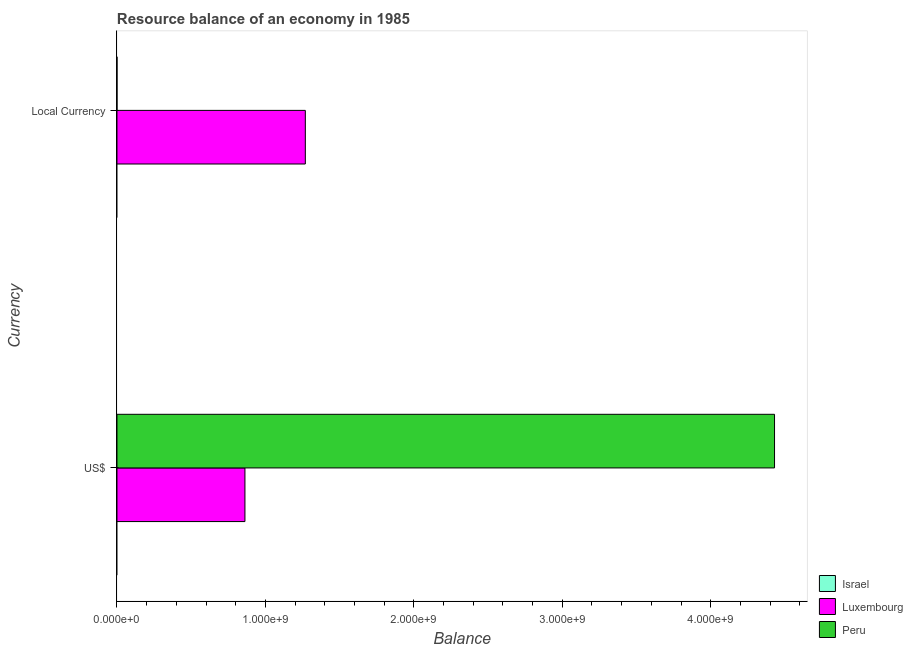How many groups of bars are there?
Give a very brief answer. 2. How many bars are there on the 1st tick from the top?
Ensure brevity in your answer.  2. What is the label of the 2nd group of bars from the top?
Your response must be concise. US$. What is the resource balance in constant us$ in Luxembourg?
Your response must be concise. 1.27e+09. Across all countries, what is the maximum resource balance in us$?
Provide a short and direct response. 4.43e+09. Across all countries, what is the minimum resource balance in constant us$?
Give a very brief answer. 0. In which country was the resource balance in constant us$ maximum?
Offer a terse response. Luxembourg. What is the total resource balance in us$ in the graph?
Provide a short and direct response. 5.29e+09. What is the difference between the resource balance in us$ in Luxembourg and that in Peru?
Your response must be concise. -3.57e+09. What is the difference between the resource balance in us$ in Israel and the resource balance in constant us$ in Luxembourg?
Provide a short and direct response. -1.27e+09. What is the average resource balance in constant us$ per country?
Provide a succinct answer. 4.23e+08. What is the difference between the resource balance in constant us$ and resource balance in us$ in Peru?
Your answer should be very brief. -4.43e+09. In how many countries, is the resource balance in us$ greater than 800000000 units?
Offer a very short reply. 2. What is the ratio of the resource balance in constant us$ in Peru to that in Luxembourg?
Your answer should be very brief. 3.490874475876324e-5. In how many countries, is the resource balance in constant us$ greater than the average resource balance in constant us$ taken over all countries?
Offer a terse response. 1. Are all the bars in the graph horizontal?
Provide a succinct answer. Yes. How many countries are there in the graph?
Your answer should be very brief. 3. What is the difference between two consecutive major ticks on the X-axis?
Offer a very short reply. 1.00e+09. Are the values on the major ticks of X-axis written in scientific E-notation?
Your answer should be very brief. Yes. Does the graph contain any zero values?
Ensure brevity in your answer.  Yes. Does the graph contain grids?
Provide a succinct answer. No. How many legend labels are there?
Offer a terse response. 3. How are the legend labels stacked?
Your response must be concise. Vertical. What is the title of the graph?
Your response must be concise. Resource balance of an economy in 1985. Does "Kosovo" appear as one of the legend labels in the graph?
Make the answer very short. No. What is the label or title of the X-axis?
Provide a succinct answer. Balance. What is the label or title of the Y-axis?
Your answer should be compact. Currency. What is the Balance of Israel in US$?
Offer a terse response. 0. What is the Balance of Luxembourg in US$?
Make the answer very short. 8.62e+08. What is the Balance in Peru in US$?
Provide a succinct answer. 4.43e+09. What is the Balance in Israel in Local Currency?
Keep it short and to the point. 0. What is the Balance in Luxembourg in Local Currency?
Keep it short and to the point. 1.27e+09. What is the Balance of Peru in Local Currency?
Provide a short and direct response. 4.43e+04. Across all Currency, what is the maximum Balance in Luxembourg?
Give a very brief answer. 1.27e+09. Across all Currency, what is the maximum Balance of Peru?
Provide a short and direct response. 4.43e+09. Across all Currency, what is the minimum Balance in Luxembourg?
Provide a succinct answer. 8.62e+08. Across all Currency, what is the minimum Balance in Peru?
Keep it short and to the point. 4.43e+04. What is the total Balance in Israel in the graph?
Provide a succinct answer. 0. What is the total Balance in Luxembourg in the graph?
Keep it short and to the point. 2.13e+09. What is the total Balance of Peru in the graph?
Keep it short and to the point. 4.43e+09. What is the difference between the Balance of Luxembourg in US$ and that in Local Currency?
Give a very brief answer. -4.07e+08. What is the difference between the Balance of Peru in US$ and that in Local Currency?
Provide a short and direct response. 4.43e+09. What is the difference between the Balance of Luxembourg in US$ and the Balance of Peru in Local Currency?
Keep it short and to the point. 8.62e+08. What is the average Balance in Israel per Currency?
Offer a very short reply. 0. What is the average Balance of Luxembourg per Currency?
Your answer should be very brief. 1.07e+09. What is the average Balance in Peru per Currency?
Give a very brief answer. 2.22e+09. What is the difference between the Balance in Luxembourg and Balance in Peru in US$?
Offer a very short reply. -3.57e+09. What is the difference between the Balance in Luxembourg and Balance in Peru in Local Currency?
Make the answer very short. 1.27e+09. What is the ratio of the Balance of Luxembourg in US$ to that in Local Currency?
Give a very brief answer. 0.68. What is the ratio of the Balance of Peru in US$ to that in Local Currency?
Your answer should be very brief. 1.00e+05. What is the difference between the highest and the second highest Balance in Luxembourg?
Provide a succinct answer. 4.07e+08. What is the difference between the highest and the second highest Balance in Peru?
Your response must be concise. 4.43e+09. What is the difference between the highest and the lowest Balance in Luxembourg?
Your answer should be compact. 4.07e+08. What is the difference between the highest and the lowest Balance in Peru?
Offer a terse response. 4.43e+09. 